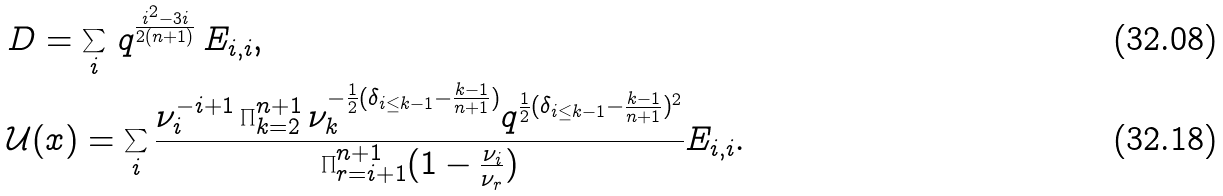<formula> <loc_0><loc_0><loc_500><loc_500>& D = \sum _ { i } \, q ^ { \frac { i ^ { 2 } - 3 i } { 2 ( n + 1 ) } } \, E _ { i , i } , \\ & \mathcal { U } ( x ) = \sum _ { i } \frac { \nu _ { i } ^ { - i + 1 } \prod _ { k = 2 } ^ { n + 1 } \nu _ { k } ^ { - \frac { 1 } { 2 } ( \delta _ { i \leq k - 1 } - \frac { k - 1 } { n + 1 } ) } q ^ { \frac { 1 } { 2 } ( \delta _ { i \leq k - 1 } - \frac { k - 1 } { n + 1 } ) ^ { 2 } } } { \prod _ { r = i + 1 } ^ { n + 1 } ( 1 - \frac { \nu _ { i } } { \nu _ { r } } ) } E _ { i , i } .</formula> 